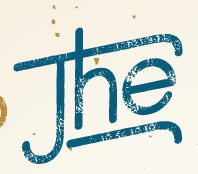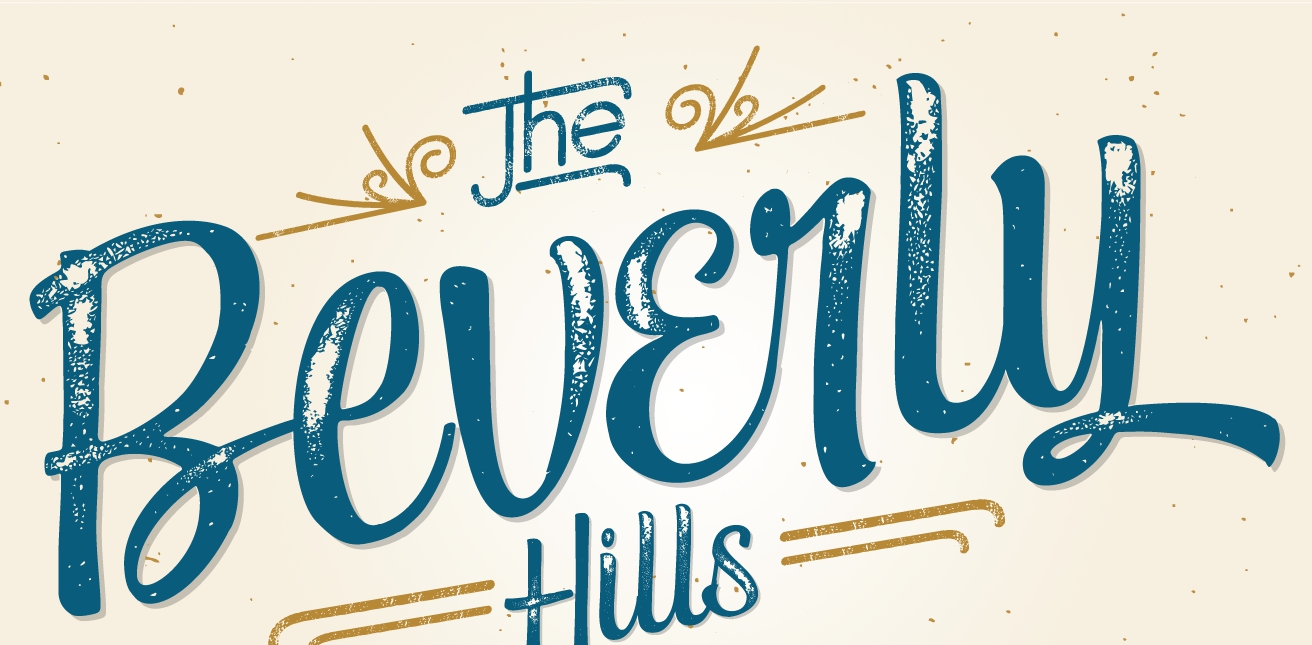Read the text from these images in sequence, separated by a semicolon. The; Beverly 